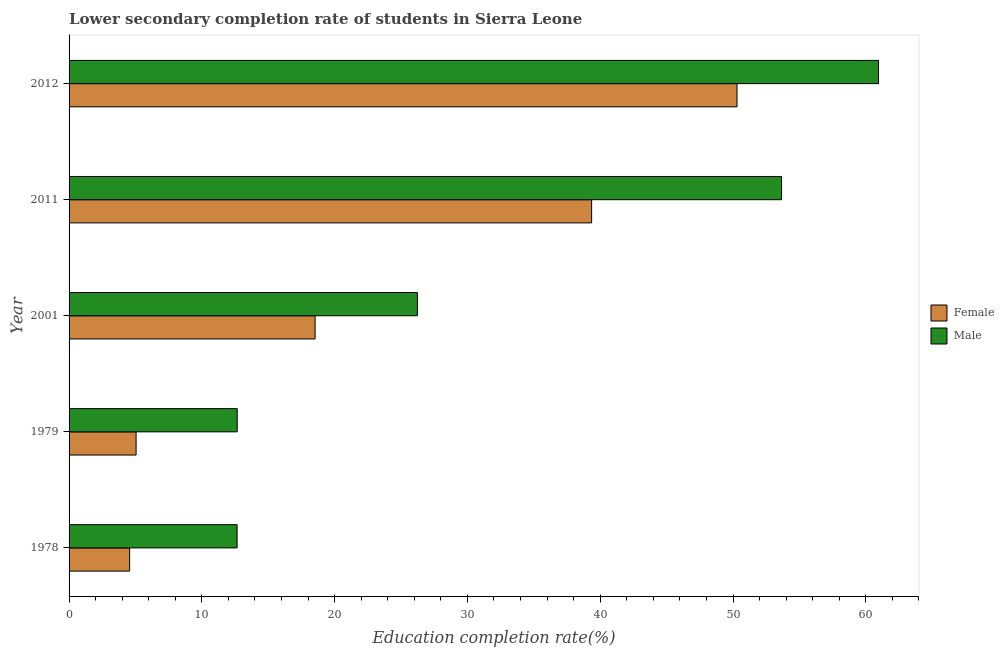How many groups of bars are there?
Offer a very short reply. 5. Are the number of bars on each tick of the Y-axis equal?
Offer a very short reply. Yes. What is the label of the 1st group of bars from the top?
Make the answer very short. 2012. In how many cases, is the number of bars for a given year not equal to the number of legend labels?
Give a very brief answer. 0. What is the education completion rate of female students in 1979?
Provide a succinct answer. 5.05. Across all years, what is the maximum education completion rate of female students?
Ensure brevity in your answer.  50.3. Across all years, what is the minimum education completion rate of female students?
Make the answer very short. 4.56. In which year was the education completion rate of female students maximum?
Provide a succinct answer. 2012. In which year was the education completion rate of female students minimum?
Offer a very short reply. 1978. What is the total education completion rate of female students in the graph?
Offer a terse response. 117.79. What is the difference between the education completion rate of male students in 2011 and that in 2012?
Offer a terse response. -7.3. What is the difference between the education completion rate of female students in 2011 and the education completion rate of male students in 2001?
Ensure brevity in your answer.  13.12. What is the average education completion rate of male students per year?
Your answer should be very brief. 33.23. In the year 2011, what is the difference between the education completion rate of female students and education completion rate of male students?
Ensure brevity in your answer.  -14.3. In how many years, is the education completion rate of male students greater than 2 %?
Ensure brevity in your answer.  5. What is the ratio of the education completion rate of female students in 1979 to that in 2011?
Your answer should be very brief. 0.13. Is the difference between the education completion rate of female students in 2001 and 2011 greater than the difference between the education completion rate of male students in 2001 and 2011?
Your answer should be compact. Yes. What is the difference between the highest and the second highest education completion rate of female students?
Give a very brief answer. 10.95. What is the difference between the highest and the lowest education completion rate of male students?
Offer a very short reply. 48.3. How many bars are there?
Keep it short and to the point. 10. Are all the bars in the graph horizontal?
Offer a terse response. Yes. Are the values on the major ticks of X-axis written in scientific E-notation?
Ensure brevity in your answer.  No. How many legend labels are there?
Provide a succinct answer. 2. What is the title of the graph?
Ensure brevity in your answer.  Lower secondary completion rate of students in Sierra Leone. Does "From Government" appear as one of the legend labels in the graph?
Offer a very short reply. No. What is the label or title of the X-axis?
Your answer should be compact. Education completion rate(%). What is the label or title of the Y-axis?
Your response must be concise. Year. What is the Education completion rate(%) in Female in 1978?
Ensure brevity in your answer.  4.56. What is the Education completion rate(%) of Male in 1978?
Ensure brevity in your answer.  12.65. What is the Education completion rate(%) of Female in 1979?
Your answer should be compact. 5.05. What is the Education completion rate(%) in Male in 1979?
Make the answer very short. 12.66. What is the Education completion rate(%) of Female in 2001?
Provide a succinct answer. 18.53. What is the Education completion rate(%) in Male in 2001?
Provide a succinct answer. 26.23. What is the Education completion rate(%) of Female in 2011?
Offer a very short reply. 39.35. What is the Education completion rate(%) of Male in 2011?
Offer a very short reply. 53.66. What is the Education completion rate(%) of Female in 2012?
Give a very brief answer. 50.3. What is the Education completion rate(%) of Male in 2012?
Keep it short and to the point. 60.96. Across all years, what is the maximum Education completion rate(%) in Female?
Your answer should be compact. 50.3. Across all years, what is the maximum Education completion rate(%) in Male?
Your answer should be compact. 60.96. Across all years, what is the minimum Education completion rate(%) of Female?
Your response must be concise. 4.56. Across all years, what is the minimum Education completion rate(%) of Male?
Make the answer very short. 12.65. What is the total Education completion rate(%) in Female in the graph?
Provide a succinct answer. 117.79. What is the total Education completion rate(%) in Male in the graph?
Your answer should be compact. 166.17. What is the difference between the Education completion rate(%) of Female in 1978 and that in 1979?
Provide a succinct answer. -0.49. What is the difference between the Education completion rate(%) of Male in 1978 and that in 1979?
Your answer should be very brief. -0.01. What is the difference between the Education completion rate(%) in Female in 1978 and that in 2001?
Your answer should be compact. -13.97. What is the difference between the Education completion rate(%) of Male in 1978 and that in 2001?
Offer a terse response. -13.58. What is the difference between the Education completion rate(%) of Female in 1978 and that in 2011?
Provide a succinct answer. -34.79. What is the difference between the Education completion rate(%) of Male in 1978 and that in 2011?
Your response must be concise. -41. What is the difference between the Education completion rate(%) in Female in 1978 and that in 2012?
Your answer should be compact. -45.74. What is the difference between the Education completion rate(%) in Male in 1978 and that in 2012?
Provide a short and direct response. -48.3. What is the difference between the Education completion rate(%) of Female in 1979 and that in 2001?
Provide a succinct answer. -13.48. What is the difference between the Education completion rate(%) of Male in 1979 and that in 2001?
Offer a terse response. -13.57. What is the difference between the Education completion rate(%) in Female in 1979 and that in 2011?
Your answer should be very brief. -34.31. What is the difference between the Education completion rate(%) in Male in 1979 and that in 2011?
Keep it short and to the point. -41. What is the difference between the Education completion rate(%) of Female in 1979 and that in 2012?
Provide a short and direct response. -45.26. What is the difference between the Education completion rate(%) in Male in 1979 and that in 2012?
Offer a terse response. -48.29. What is the difference between the Education completion rate(%) of Female in 2001 and that in 2011?
Make the answer very short. -20.83. What is the difference between the Education completion rate(%) in Male in 2001 and that in 2011?
Make the answer very short. -27.43. What is the difference between the Education completion rate(%) in Female in 2001 and that in 2012?
Give a very brief answer. -31.78. What is the difference between the Education completion rate(%) of Male in 2001 and that in 2012?
Ensure brevity in your answer.  -34.73. What is the difference between the Education completion rate(%) in Female in 2011 and that in 2012?
Ensure brevity in your answer.  -10.95. What is the difference between the Education completion rate(%) in Male in 2011 and that in 2012?
Offer a terse response. -7.3. What is the difference between the Education completion rate(%) of Female in 1978 and the Education completion rate(%) of Male in 1979?
Keep it short and to the point. -8.1. What is the difference between the Education completion rate(%) in Female in 1978 and the Education completion rate(%) in Male in 2001?
Provide a succinct answer. -21.67. What is the difference between the Education completion rate(%) of Female in 1978 and the Education completion rate(%) of Male in 2011?
Your response must be concise. -49.1. What is the difference between the Education completion rate(%) in Female in 1978 and the Education completion rate(%) in Male in 2012?
Offer a very short reply. -56.4. What is the difference between the Education completion rate(%) of Female in 1979 and the Education completion rate(%) of Male in 2001?
Your answer should be very brief. -21.18. What is the difference between the Education completion rate(%) in Female in 1979 and the Education completion rate(%) in Male in 2011?
Ensure brevity in your answer.  -48.61. What is the difference between the Education completion rate(%) of Female in 1979 and the Education completion rate(%) of Male in 2012?
Offer a very short reply. -55.91. What is the difference between the Education completion rate(%) of Female in 2001 and the Education completion rate(%) of Male in 2011?
Provide a short and direct response. -35.13. What is the difference between the Education completion rate(%) of Female in 2001 and the Education completion rate(%) of Male in 2012?
Your answer should be compact. -42.43. What is the difference between the Education completion rate(%) of Female in 2011 and the Education completion rate(%) of Male in 2012?
Keep it short and to the point. -21.6. What is the average Education completion rate(%) in Female per year?
Give a very brief answer. 23.56. What is the average Education completion rate(%) of Male per year?
Provide a short and direct response. 33.23. In the year 1978, what is the difference between the Education completion rate(%) of Female and Education completion rate(%) of Male?
Ensure brevity in your answer.  -8.09. In the year 1979, what is the difference between the Education completion rate(%) in Female and Education completion rate(%) in Male?
Give a very brief answer. -7.62. In the year 2001, what is the difference between the Education completion rate(%) in Female and Education completion rate(%) in Male?
Make the answer very short. -7.7. In the year 2011, what is the difference between the Education completion rate(%) of Female and Education completion rate(%) of Male?
Your response must be concise. -14.3. In the year 2012, what is the difference between the Education completion rate(%) in Female and Education completion rate(%) in Male?
Your answer should be very brief. -10.65. What is the ratio of the Education completion rate(%) in Female in 1978 to that in 1979?
Offer a very short reply. 0.9. What is the ratio of the Education completion rate(%) in Male in 1978 to that in 1979?
Give a very brief answer. 1. What is the ratio of the Education completion rate(%) of Female in 1978 to that in 2001?
Provide a succinct answer. 0.25. What is the ratio of the Education completion rate(%) of Male in 1978 to that in 2001?
Ensure brevity in your answer.  0.48. What is the ratio of the Education completion rate(%) in Female in 1978 to that in 2011?
Give a very brief answer. 0.12. What is the ratio of the Education completion rate(%) of Male in 1978 to that in 2011?
Offer a very short reply. 0.24. What is the ratio of the Education completion rate(%) in Female in 1978 to that in 2012?
Offer a very short reply. 0.09. What is the ratio of the Education completion rate(%) in Male in 1978 to that in 2012?
Provide a short and direct response. 0.21. What is the ratio of the Education completion rate(%) of Female in 1979 to that in 2001?
Offer a very short reply. 0.27. What is the ratio of the Education completion rate(%) in Male in 1979 to that in 2001?
Ensure brevity in your answer.  0.48. What is the ratio of the Education completion rate(%) in Female in 1979 to that in 2011?
Your response must be concise. 0.13. What is the ratio of the Education completion rate(%) of Male in 1979 to that in 2011?
Your answer should be compact. 0.24. What is the ratio of the Education completion rate(%) of Female in 1979 to that in 2012?
Offer a very short reply. 0.1. What is the ratio of the Education completion rate(%) in Male in 1979 to that in 2012?
Keep it short and to the point. 0.21. What is the ratio of the Education completion rate(%) in Female in 2001 to that in 2011?
Your response must be concise. 0.47. What is the ratio of the Education completion rate(%) in Male in 2001 to that in 2011?
Give a very brief answer. 0.49. What is the ratio of the Education completion rate(%) of Female in 2001 to that in 2012?
Your response must be concise. 0.37. What is the ratio of the Education completion rate(%) of Male in 2001 to that in 2012?
Your answer should be very brief. 0.43. What is the ratio of the Education completion rate(%) in Female in 2011 to that in 2012?
Offer a very short reply. 0.78. What is the ratio of the Education completion rate(%) of Male in 2011 to that in 2012?
Ensure brevity in your answer.  0.88. What is the difference between the highest and the second highest Education completion rate(%) of Female?
Offer a very short reply. 10.95. What is the difference between the highest and the second highest Education completion rate(%) in Male?
Keep it short and to the point. 7.3. What is the difference between the highest and the lowest Education completion rate(%) in Female?
Give a very brief answer. 45.74. What is the difference between the highest and the lowest Education completion rate(%) of Male?
Provide a succinct answer. 48.3. 